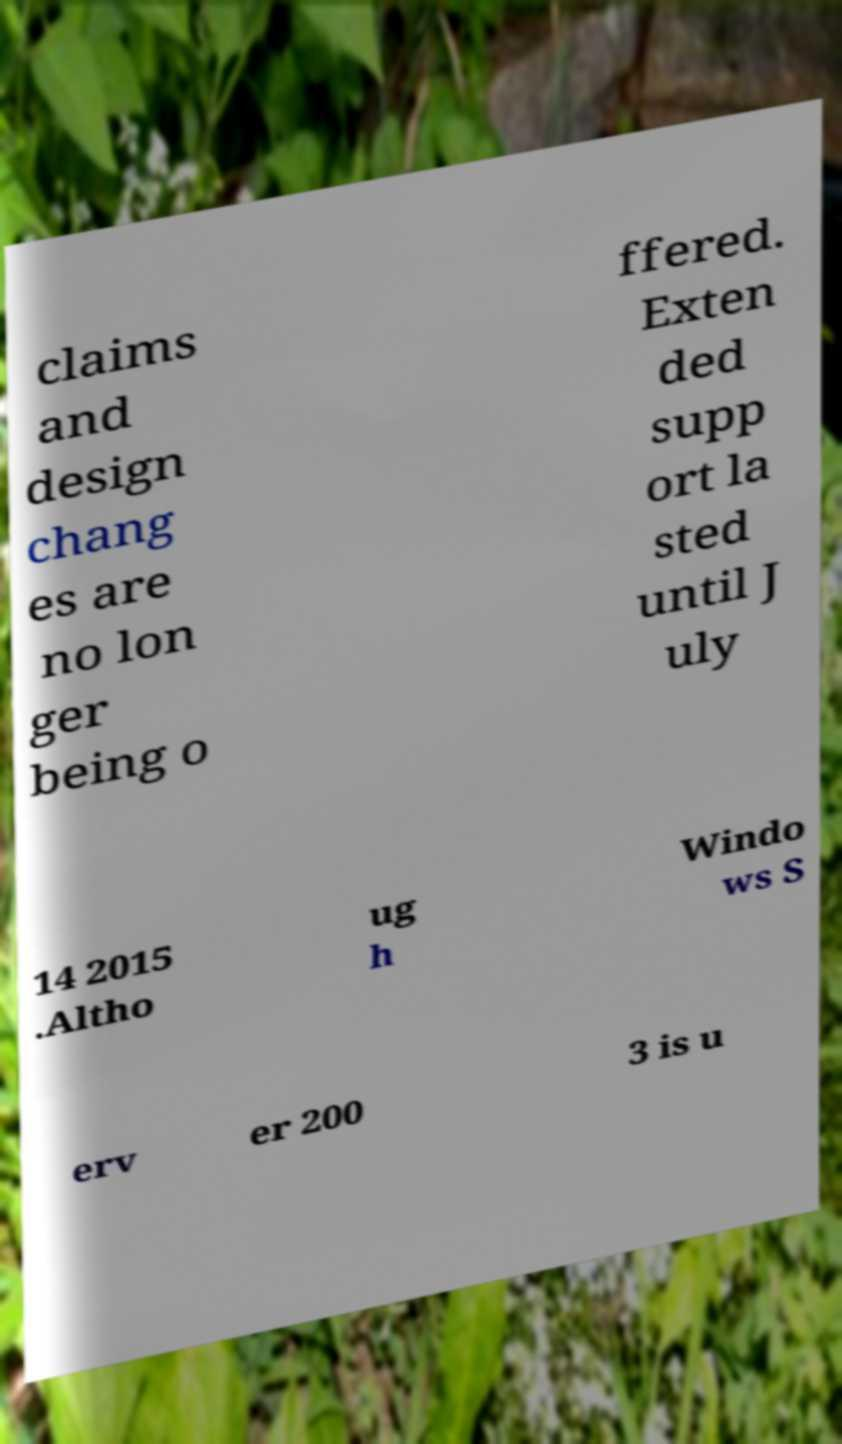I need the written content from this picture converted into text. Can you do that? claims and design chang es are no lon ger being o ffered. Exten ded supp ort la sted until J uly 14 2015 .Altho ug h Windo ws S erv er 200 3 is u 